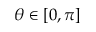Convert formula to latex. <formula><loc_0><loc_0><loc_500><loc_500>\theta \in [ 0 , \pi ]</formula> 